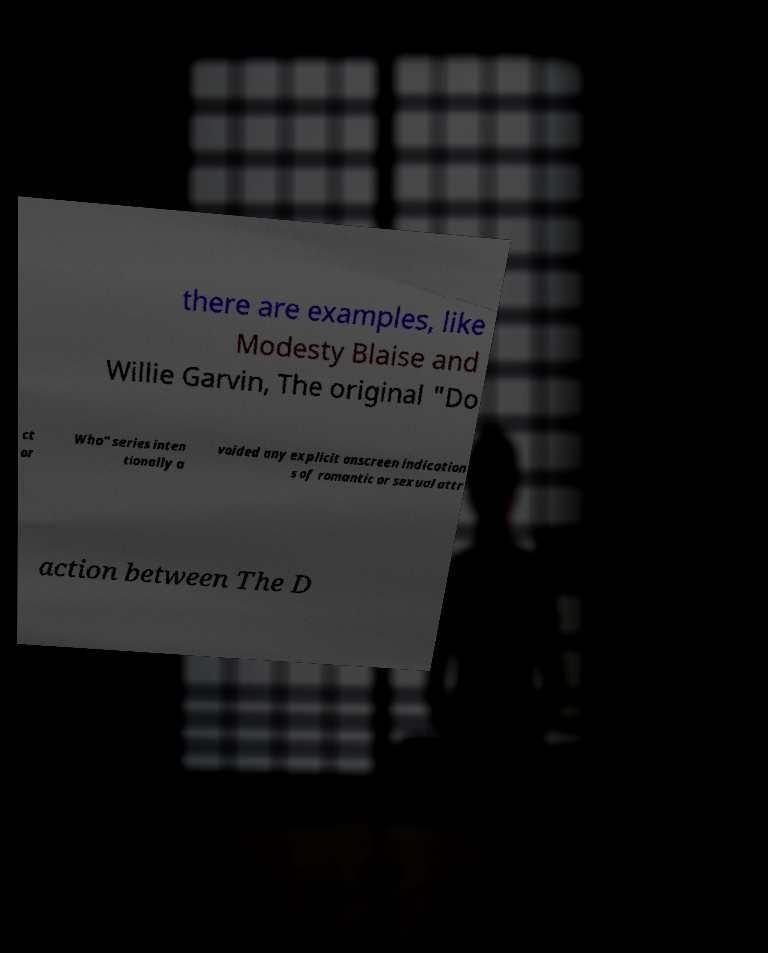What messages or text are displayed in this image? I need them in a readable, typed format. there are examples, like Modesty Blaise and Willie Garvin, The original "Do ct or Who" series inten tionally a voided any explicit onscreen indication s of romantic or sexual attr action between The D 